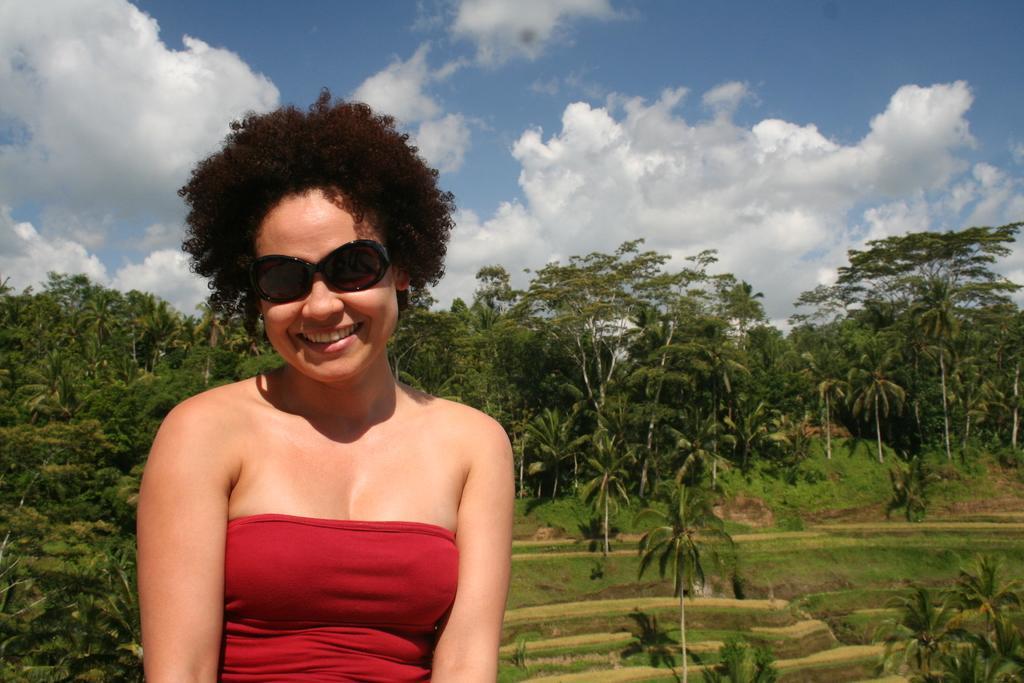Please provide a concise description of this image. In this picture I can see a woman wore sunglasses and I can see smile on her face and few trees and a blue cloudy sky. 